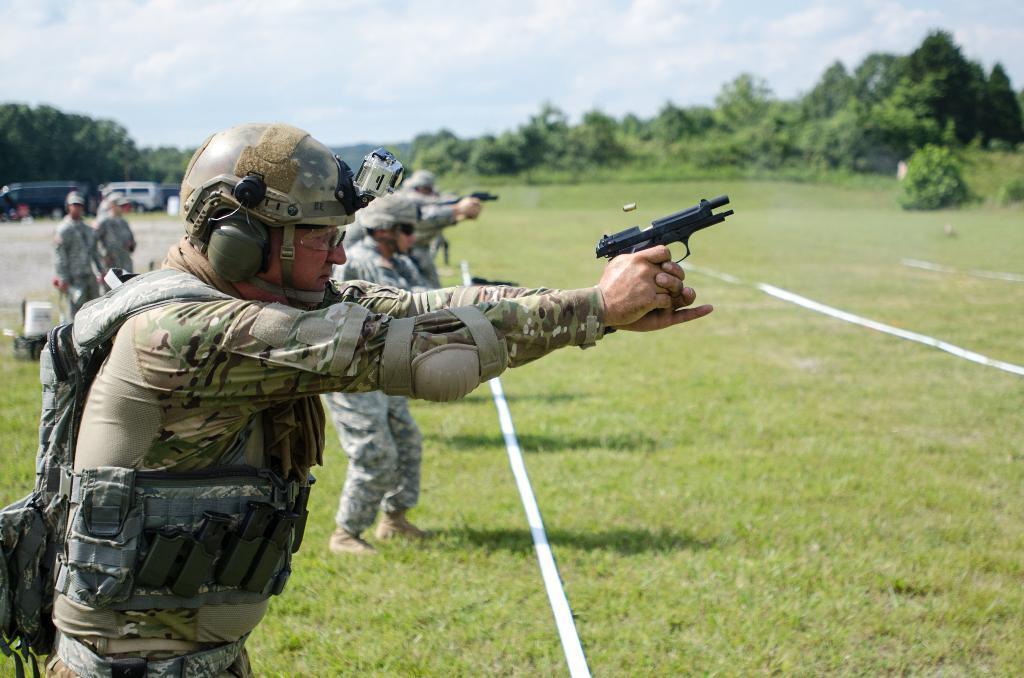Could you give a brief overview of what you see in this image? In this image I see number of persons in which all of them are wearing army uniforms and I see that few of them are holding guns in their hands and I see the green grass on which there are white lines. In the background I see number of trees and I see vehicles over here and I see the sky. 